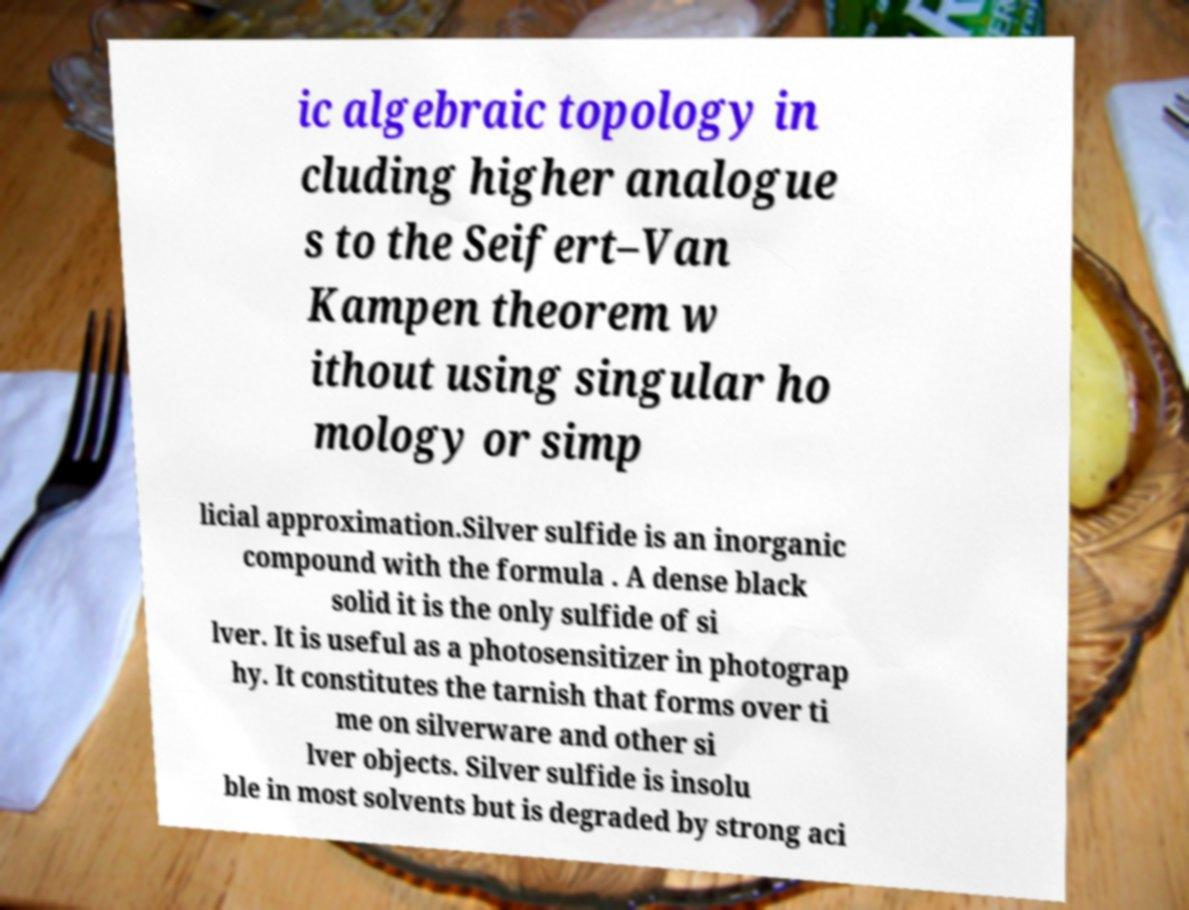Can you read and provide the text displayed in the image?This photo seems to have some interesting text. Can you extract and type it out for me? ic algebraic topology in cluding higher analogue s to the Seifert–Van Kampen theorem w ithout using singular ho mology or simp licial approximation.Silver sulfide is an inorganic compound with the formula . A dense black solid it is the only sulfide of si lver. It is useful as a photosensitizer in photograp hy. It constitutes the tarnish that forms over ti me on silverware and other si lver objects. Silver sulfide is insolu ble in most solvents but is degraded by strong aci 